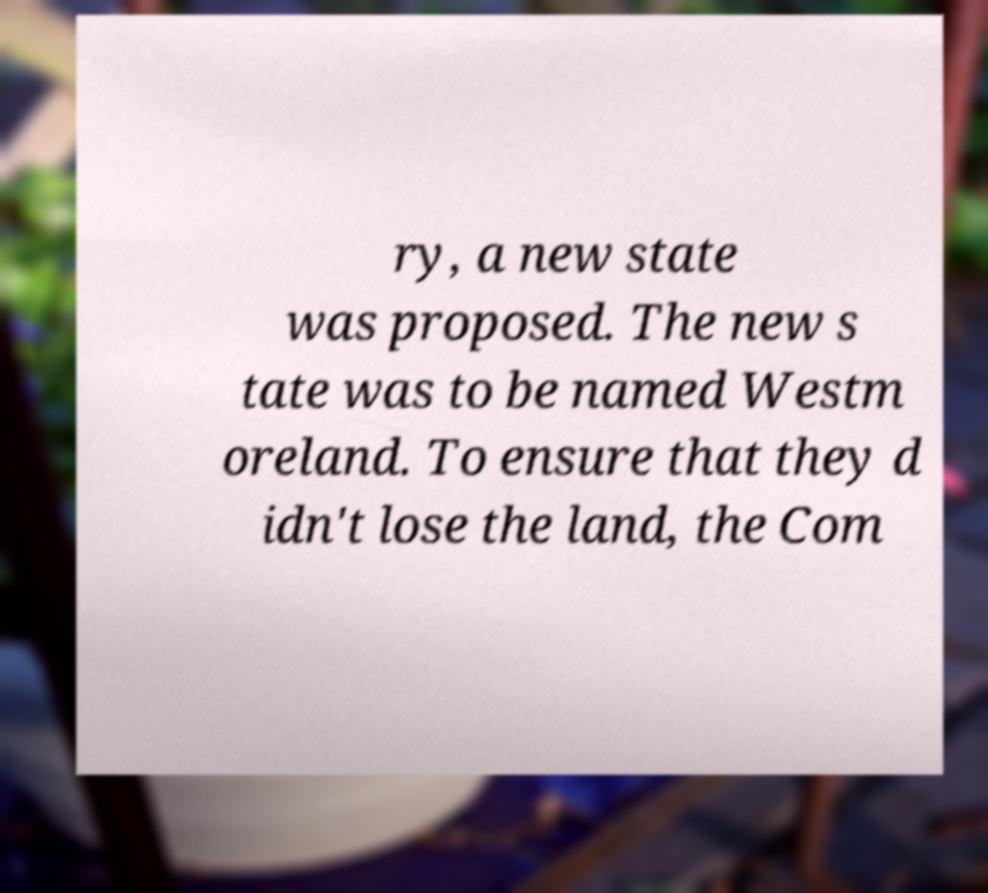Please identify and transcribe the text found in this image. ry, a new state was proposed. The new s tate was to be named Westm oreland. To ensure that they d idn't lose the land, the Com 